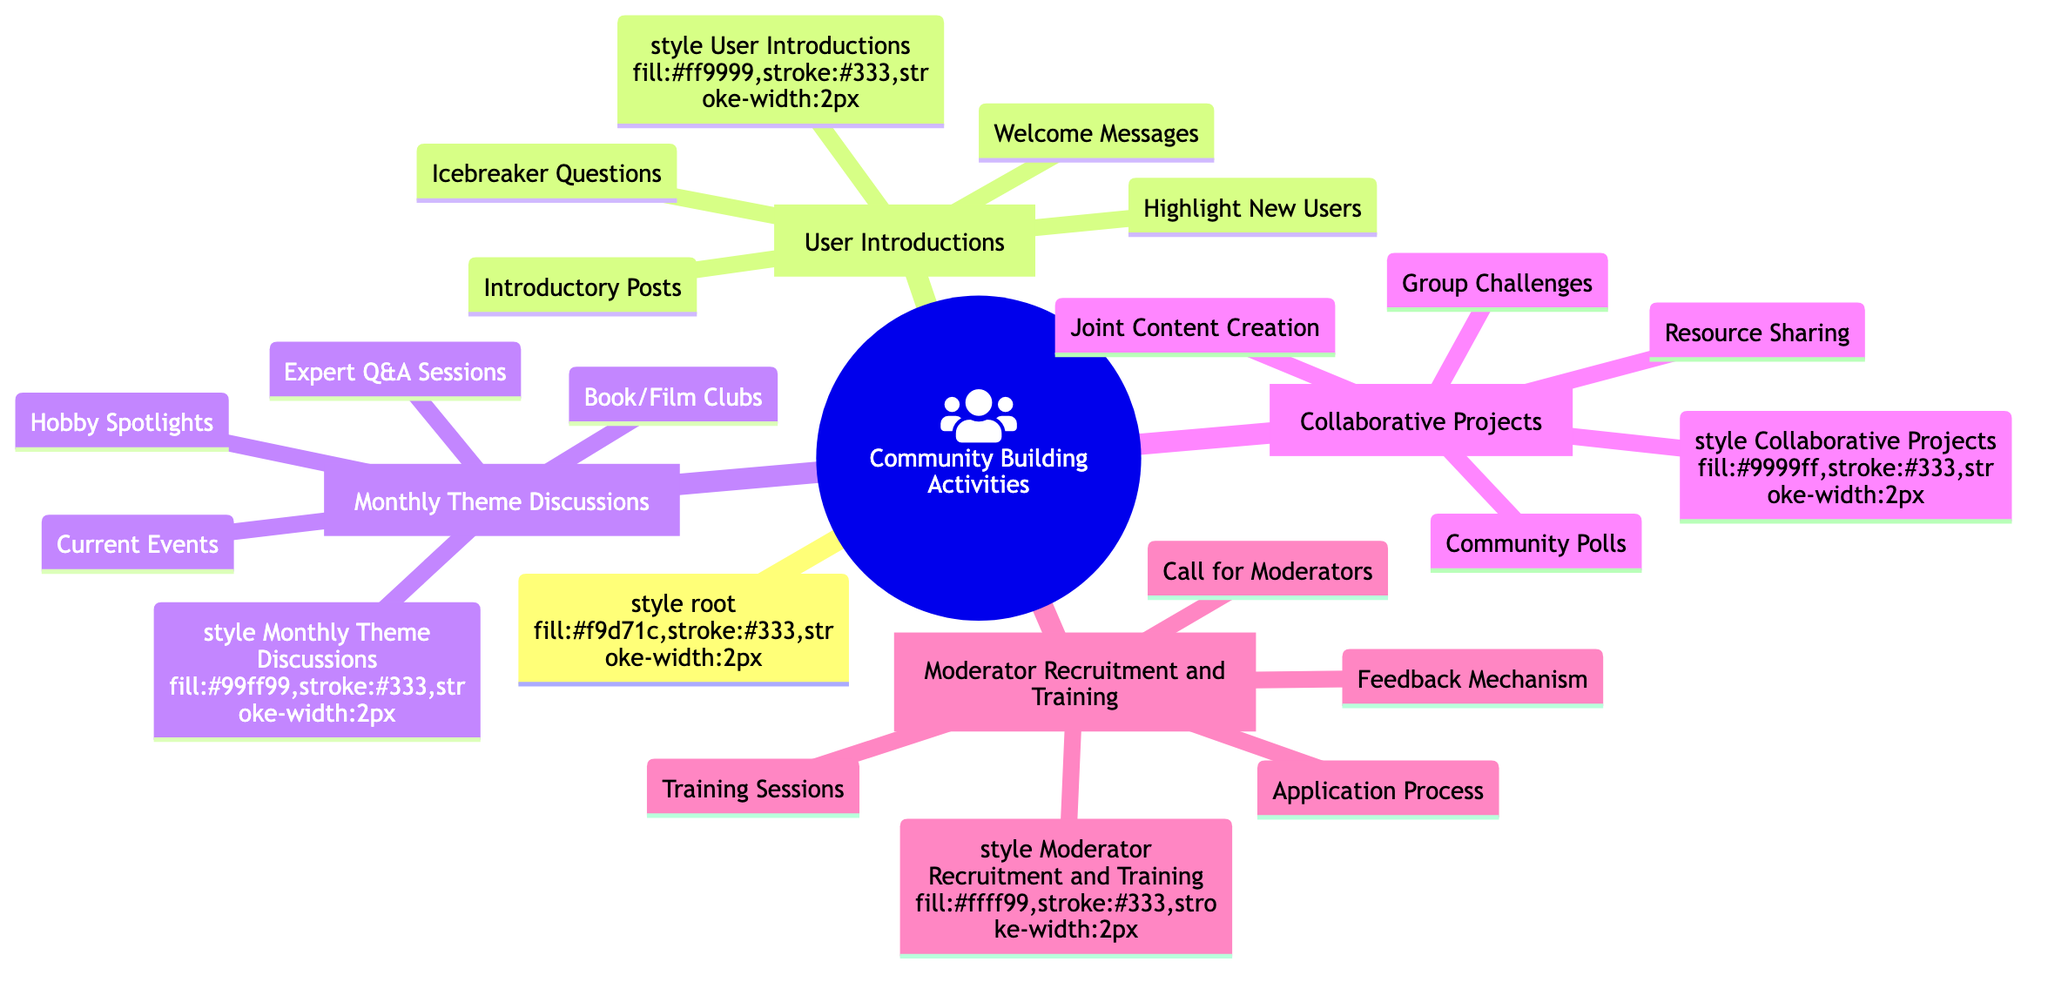What are the four main categories of community building activities? The diagram shows four main categories branching from the central node: User Introductions, Monthly Theme Discussions, Collaborative Projects, and Moderator Recruitment and Training.
Answer: User Introductions, Monthly Theme Discussions, Collaborative Projects, Moderator Recruitment and Training How many subcategories are under Collaborative Projects? Under the Collaborative Projects category, there are four subcategories listed: Community Polls, Group Challenges, Resource Sharing, and Joint Content Creation. Count these to find the answer.
Answer: 4 What is one activity under User Introductions that highlights new users? The diagram specifies that "Highlight New Users" is an activity under User Introductions that emphasizes new members in a weekly post.
Answer: Highlight New Users Which subcategory includes discussions on trending news? The diagram lists "Current Events" under Monthly Theme Discussions, indicating this is where discussions about trending news occur.
Answer: Current Events What action is involved in the Application Process for Moderator Recruitment? The diagram shows that there is a specific section called "Application Process" that details the steps on how to apply for moderator roles, indicating a structured approach.
Answer: Detailed steps on how to apply for moderator roles How do Collaborative Projects encourage user involvement? The diagram consists of activities such as Community Polls, Group Challenges, Resource Sharing, and Joint Content Creation under Collaborative Projects, all of which encourage active participation from the community members.
Answer: Active participation Which category features training for moderators? The section labeled "Training Sessions" is found under the Moderator Recruitment and Training category, indicating it focuses on providing training for moderators.
Answer: Training Sessions How many activities are listed under Monthly Theme Discussions? The Monthly Theme Discussions branch includes four activities: Current Events, Hobby Spotlights, Book/Film Clubs, and Expert Q&A Sessions. Count these to determine the total number of activities.
Answer: 4 What type of feedback mechanism is mentioned for moderators? The diagram includes "Continuous feedback to and from moderators to improve community management," indicating that there is a system for feedback involved in moderator recruitment and training.
Answer: Continuous feedback 